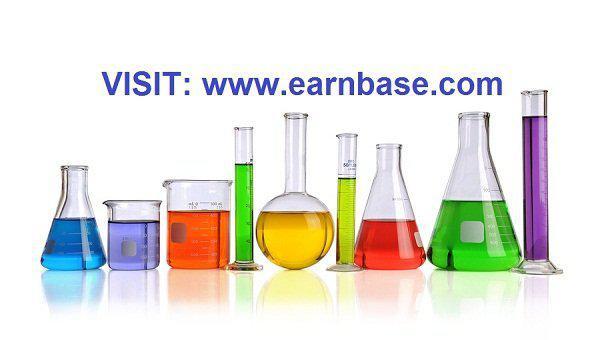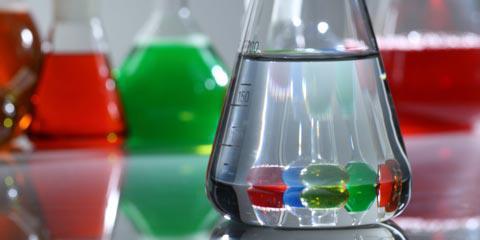The first image is the image on the left, the second image is the image on the right. Assess this claim about the two images: "In at least one image, the container on the far right contains a reddish liquid.". Correct or not? Answer yes or no. Yes. 